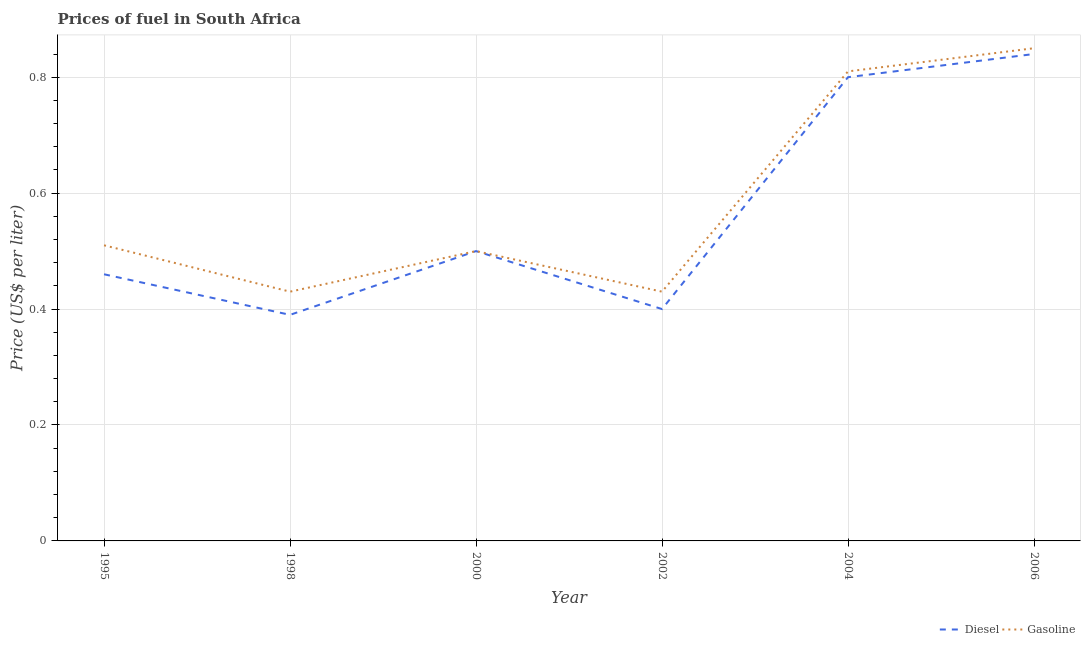How many different coloured lines are there?
Provide a short and direct response. 2. Does the line corresponding to gasoline price intersect with the line corresponding to diesel price?
Make the answer very short. Yes. Is the number of lines equal to the number of legend labels?
Your answer should be compact. Yes. Across all years, what is the maximum gasoline price?
Provide a succinct answer. 0.85. Across all years, what is the minimum diesel price?
Provide a succinct answer. 0.39. What is the total diesel price in the graph?
Keep it short and to the point. 3.39. What is the difference between the diesel price in 1998 and that in 2000?
Offer a terse response. -0.11. What is the difference between the gasoline price in 1998 and the diesel price in 2000?
Make the answer very short. -0.07. What is the average diesel price per year?
Provide a succinct answer. 0.56. In the year 1995, what is the difference between the diesel price and gasoline price?
Your answer should be very brief. -0.05. What is the ratio of the diesel price in 1995 to that in 2002?
Make the answer very short. 1.15. Is the difference between the diesel price in 1995 and 2006 greater than the difference between the gasoline price in 1995 and 2006?
Give a very brief answer. No. What is the difference between the highest and the second highest diesel price?
Provide a succinct answer. 0.04. What is the difference between the highest and the lowest gasoline price?
Your answer should be very brief. 0.42. In how many years, is the diesel price greater than the average diesel price taken over all years?
Provide a short and direct response. 2. Is the sum of the diesel price in 2004 and 2006 greater than the maximum gasoline price across all years?
Ensure brevity in your answer.  Yes. Does the gasoline price monotonically increase over the years?
Offer a terse response. No. Is the diesel price strictly greater than the gasoline price over the years?
Your response must be concise. No. Is the diesel price strictly less than the gasoline price over the years?
Give a very brief answer. No. How many years are there in the graph?
Give a very brief answer. 6. What is the difference between two consecutive major ticks on the Y-axis?
Make the answer very short. 0.2. Are the values on the major ticks of Y-axis written in scientific E-notation?
Ensure brevity in your answer.  No. Where does the legend appear in the graph?
Your answer should be compact. Bottom right. What is the title of the graph?
Keep it short and to the point. Prices of fuel in South Africa. Does "Register a property" appear as one of the legend labels in the graph?
Provide a succinct answer. No. What is the label or title of the X-axis?
Ensure brevity in your answer.  Year. What is the label or title of the Y-axis?
Your answer should be compact. Price (US$ per liter). What is the Price (US$ per liter) in Diesel in 1995?
Your response must be concise. 0.46. What is the Price (US$ per liter) of Gasoline in 1995?
Make the answer very short. 0.51. What is the Price (US$ per liter) in Diesel in 1998?
Your answer should be very brief. 0.39. What is the Price (US$ per liter) of Gasoline in 1998?
Your response must be concise. 0.43. What is the Price (US$ per liter) in Diesel in 2000?
Offer a very short reply. 0.5. What is the Price (US$ per liter) of Gasoline in 2000?
Your response must be concise. 0.5. What is the Price (US$ per liter) of Diesel in 2002?
Ensure brevity in your answer.  0.4. What is the Price (US$ per liter) in Gasoline in 2002?
Provide a succinct answer. 0.43. What is the Price (US$ per liter) of Gasoline in 2004?
Your answer should be compact. 0.81. What is the Price (US$ per liter) of Diesel in 2006?
Provide a short and direct response. 0.84. Across all years, what is the maximum Price (US$ per liter) in Diesel?
Make the answer very short. 0.84. Across all years, what is the maximum Price (US$ per liter) in Gasoline?
Your answer should be very brief. 0.85. Across all years, what is the minimum Price (US$ per liter) of Diesel?
Ensure brevity in your answer.  0.39. Across all years, what is the minimum Price (US$ per liter) in Gasoline?
Your answer should be compact. 0.43. What is the total Price (US$ per liter) of Diesel in the graph?
Give a very brief answer. 3.39. What is the total Price (US$ per liter) in Gasoline in the graph?
Make the answer very short. 3.53. What is the difference between the Price (US$ per liter) in Diesel in 1995 and that in 1998?
Offer a terse response. 0.07. What is the difference between the Price (US$ per liter) of Gasoline in 1995 and that in 1998?
Make the answer very short. 0.08. What is the difference between the Price (US$ per liter) of Diesel in 1995 and that in 2000?
Provide a succinct answer. -0.04. What is the difference between the Price (US$ per liter) of Gasoline in 1995 and that in 2000?
Make the answer very short. 0.01. What is the difference between the Price (US$ per liter) of Diesel in 1995 and that in 2002?
Offer a terse response. 0.06. What is the difference between the Price (US$ per liter) of Gasoline in 1995 and that in 2002?
Provide a succinct answer. 0.08. What is the difference between the Price (US$ per liter) in Diesel in 1995 and that in 2004?
Make the answer very short. -0.34. What is the difference between the Price (US$ per liter) in Diesel in 1995 and that in 2006?
Provide a succinct answer. -0.38. What is the difference between the Price (US$ per liter) in Gasoline in 1995 and that in 2006?
Your response must be concise. -0.34. What is the difference between the Price (US$ per liter) in Diesel in 1998 and that in 2000?
Give a very brief answer. -0.11. What is the difference between the Price (US$ per liter) in Gasoline in 1998 and that in 2000?
Your answer should be very brief. -0.07. What is the difference between the Price (US$ per liter) in Diesel in 1998 and that in 2002?
Your answer should be very brief. -0.01. What is the difference between the Price (US$ per liter) in Gasoline in 1998 and that in 2002?
Your answer should be compact. 0. What is the difference between the Price (US$ per liter) of Diesel in 1998 and that in 2004?
Keep it short and to the point. -0.41. What is the difference between the Price (US$ per liter) in Gasoline in 1998 and that in 2004?
Your answer should be very brief. -0.38. What is the difference between the Price (US$ per liter) of Diesel in 1998 and that in 2006?
Keep it short and to the point. -0.45. What is the difference between the Price (US$ per liter) in Gasoline in 1998 and that in 2006?
Provide a succinct answer. -0.42. What is the difference between the Price (US$ per liter) of Diesel in 2000 and that in 2002?
Offer a very short reply. 0.1. What is the difference between the Price (US$ per liter) in Gasoline in 2000 and that in 2002?
Offer a very short reply. 0.07. What is the difference between the Price (US$ per liter) of Diesel in 2000 and that in 2004?
Keep it short and to the point. -0.3. What is the difference between the Price (US$ per liter) in Gasoline in 2000 and that in 2004?
Your answer should be very brief. -0.31. What is the difference between the Price (US$ per liter) of Diesel in 2000 and that in 2006?
Keep it short and to the point. -0.34. What is the difference between the Price (US$ per liter) in Gasoline in 2000 and that in 2006?
Make the answer very short. -0.35. What is the difference between the Price (US$ per liter) of Gasoline in 2002 and that in 2004?
Offer a terse response. -0.38. What is the difference between the Price (US$ per liter) in Diesel in 2002 and that in 2006?
Your answer should be very brief. -0.44. What is the difference between the Price (US$ per liter) of Gasoline in 2002 and that in 2006?
Provide a succinct answer. -0.42. What is the difference between the Price (US$ per liter) in Diesel in 2004 and that in 2006?
Provide a short and direct response. -0.04. What is the difference between the Price (US$ per liter) in Gasoline in 2004 and that in 2006?
Ensure brevity in your answer.  -0.04. What is the difference between the Price (US$ per liter) in Diesel in 1995 and the Price (US$ per liter) in Gasoline in 2000?
Your answer should be compact. -0.04. What is the difference between the Price (US$ per liter) in Diesel in 1995 and the Price (US$ per liter) in Gasoline in 2002?
Your answer should be very brief. 0.03. What is the difference between the Price (US$ per liter) of Diesel in 1995 and the Price (US$ per liter) of Gasoline in 2004?
Provide a succinct answer. -0.35. What is the difference between the Price (US$ per liter) in Diesel in 1995 and the Price (US$ per liter) in Gasoline in 2006?
Give a very brief answer. -0.39. What is the difference between the Price (US$ per liter) in Diesel in 1998 and the Price (US$ per liter) in Gasoline in 2000?
Your response must be concise. -0.11. What is the difference between the Price (US$ per liter) of Diesel in 1998 and the Price (US$ per liter) of Gasoline in 2002?
Make the answer very short. -0.04. What is the difference between the Price (US$ per liter) of Diesel in 1998 and the Price (US$ per liter) of Gasoline in 2004?
Offer a terse response. -0.42. What is the difference between the Price (US$ per liter) in Diesel in 1998 and the Price (US$ per liter) in Gasoline in 2006?
Keep it short and to the point. -0.46. What is the difference between the Price (US$ per liter) in Diesel in 2000 and the Price (US$ per liter) in Gasoline in 2002?
Your response must be concise. 0.07. What is the difference between the Price (US$ per liter) in Diesel in 2000 and the Price (US$ per liter) in Gasoline in 2004?
Keep it short and to the point. -0.31. What is the difference between the Price (US$ per liter) of Diesel in 2000 and the Price (US$ per liter) of Gasoline in 2006?
Offer a very short reply. -0.35. What is the difference between the Price (US$ per liter) in Diesel in 2002 and the Price (US$ per liter) in Gasoline in 2004?
Provide a succinct answer. -0.41. What is the difference between the Price (US$ per liter) of Diesel in 2002 and the Price (US$ per liter) of Gasoline in 2006?
Make the answer very short. -0.45. What is the average Price (US$ per liter) of Diesel per year?
Your answer should be compact. 0.56. What is the average Price (US$ per liter) in Gasoline per year?
Provide a succinct answer. 0.59. In the year 1998, what is the difference between the Price (US$ per liter) in Diesel and Price (US$ per liter) in Gasoline?
Offer a terse response. -0.04. In the year 2002, what is the difference between the Price (US$ per liter) in Diesel and Price (US$ per liter) in Gasoline?
Offer a very short reply. -0.03. In the year 2004, what is the difference between the Price (US$ per liter) of Diesel and Price (US$ per liter) of Gasoline?
Keep it short and to the point. -0.01. In the year 2006, what is the difference between the Price (US$ per liter) in Diesel and Price (US$ per liter) in Gasoline?
Give a very brief answer. -0.01. What is the ratio of the Price (US$ per liter) of Diesel in 1995 to that in 1998?
Offer a very short reply. 1.18. What is the ratio of the Price (US$ per liter) of Gasoline in 1995 to that in 1998?
Your response must be concise. 1.19. What is the ratio of the Price (US$ per liter) of Gasoline in 1995 to that in 2000?
Your response must be concise. 1.02. What is the ratio of the Price (US$ per liter) in Diesel in 1995 to that in 2002?
Ensure brevity in your answer.  1.15. What is the ratio of the Price (US$ per liter) of Gasoline in 1995 to that in 2002?
Your answer should be very brief. 1.19. What is the ratio of the Price (US$ per liter) in Diesel in 1995 to that in 2004?
Make the answer very short. 0.57. What is the ratio of the Price (US$ per liter) of Gasoline in 1995 to that in 2004?
Provide a short and direct response. 0.63. What is the ratio of the Price (US$ per liter) of Diesel in 1995 to that in 2006?
Offer a terse response. 0.55. What is the ratio of the Price (US$ per liter) in Gasoline in 1995 to that in 2006?
Keep it short and to the point. 0.6. What is the ratio of the Price (US$ per liter) in Diesel in 1998 to that in 2000?
Your answer should be very brief. 0.78. What is the ratio of the Price (US$ per liter) in Gasoline in 1998 to that in 2000?
Provide a succinct answer. 0.86. What is the ratio of the Price (US$ per liter) in Gasoline in 1998 to that in 2002?
Make the answer very short. 1. What is the ratio of the Price (US$ per liter) in Diesel in 1998 to that in 2004?
Give a very brief answer. 0.49. What is the ratio of the Price (US$ per liter) of Gasoline in 1998 to that in 2004?
Your response must be concise. 0.53. What is the ratio of the Price (US$ per liter) of Diesel in 1998 to that in 2006?
Your answer should be compact. 0.46. What is the ratio of the Price (US$ per liter) of Gasoline in 1998 to that in 2006?
Make the answer very short. 0.51. What is the ratio of the Price (US$ per liter) in Diesel in 2000 to that in 2002?
Make the answer very short. 1.25. What is the ratio of the Price (US$ per liter) in Gasoline in 2000 to that in 2002?
Your response must be concise. 1.16. What is the ratio of the Price (US$ per liter) in Diesel in 2000 to that in 2004?
Ensure brevity in your answer.  0.62. What is the ratio of the Price (US$ per liter) of Gasoline in 2000 to that in 2004?
Offer a terse response. 0.62. What is the ratio of the Price (US$ per liter) of Diesel in 2000 to that in 2006?
Your response must be concise. 0.6. What is the ratio of the Price (US$ per liter) of Gasoline in 2000 to that in 2006?
Your response must be concise. 0.59. What is the ratio of the Price (US$ per liter) in Diesel in 2002 to that in 2004?
Your response must be concise. 0.5. What is the ratio of the Price (US$ per liter) in Gasoline in 2002 to that in 2004?
Offer a very short reply. 0.53. What is the ratio of the Price (US$ per liter) in Diesel in 2002 to that in 2006?
Provide a short and direct response. 0.48. What is the ratio of the Price (US$ per liter) of Gasoline in 2002 to that in 2006?
Make the answer very short. 0.51. What is the ratio of the Price (US$ per liter) of Gasoline in 2004 to that in 2006?
Give a very brief answer. 0.95. What is the difference between the highest and the second highest Price (US$ per liter) of Diesel?
Give a very brief answer. 0.04. What is the difference between the highest and the lowest Price (US$ per liter) in Diesel?
Ensure brevity in your answer.  0.45. What is the difference between the highest and the lowest Price (US$ per liter) of Gasoline?
Offer a very short reply. 0.42. 